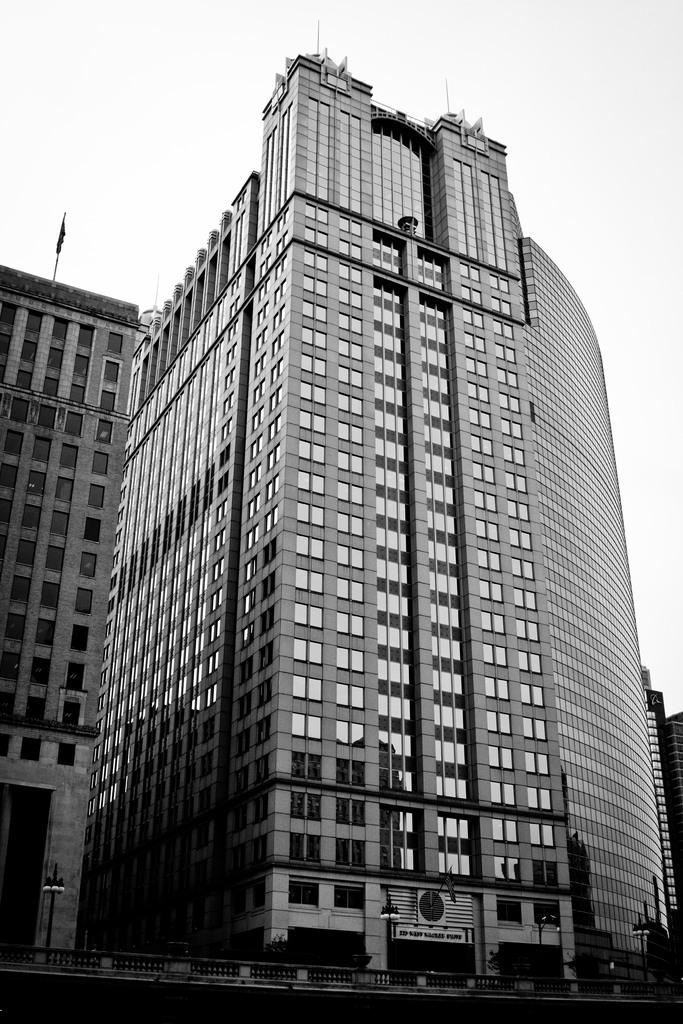What type of structures are visible in the image? There are tall buildings in the image. What type of lighting is present in the image? There are pole lights in the image. What type of barrier can be seen in the image? There is a fence in the image. What is the condition of the sky in the image? The sky is cloudy in the image. What feature can be seen on one of the buildings? There is a flag pole on one of the buildings. Can you hear the sound of the birds flying in the image? There are no birds present in the image, so it is not possible to hear any sounds related to them. 